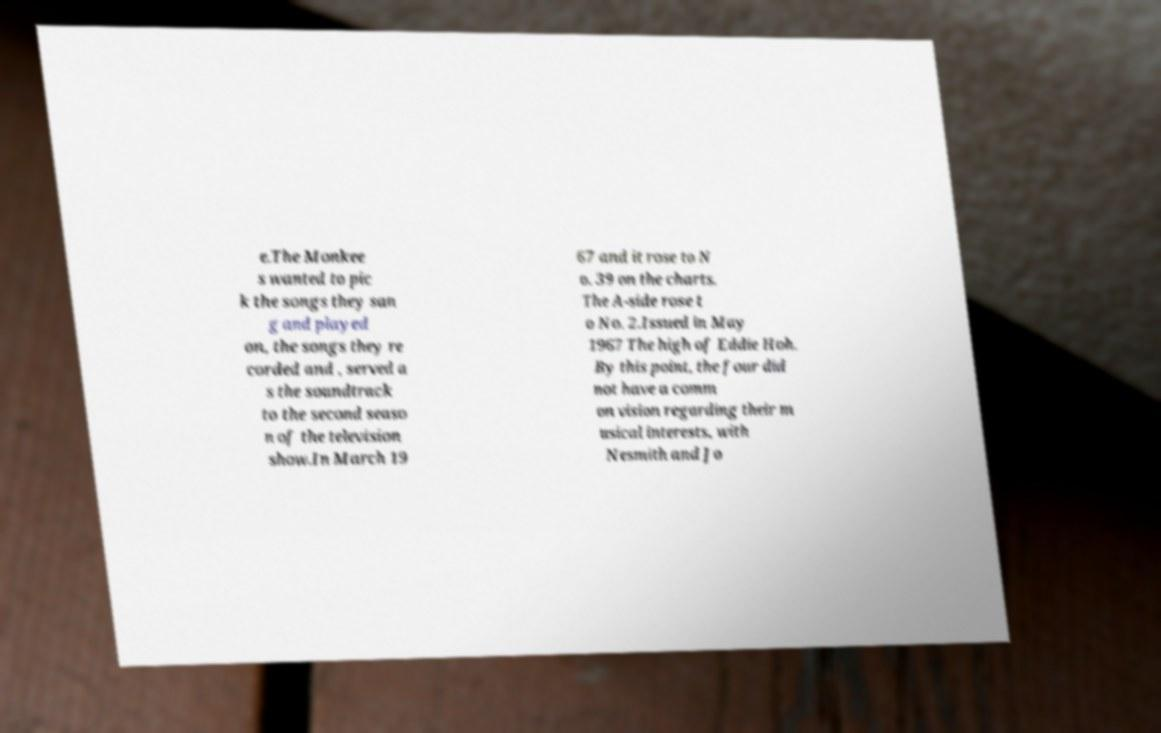Please identify and transcribe the text found in this image. e.The Monkee s wanted to pic k the songs they san g and played on, the songs they re corded and , served a s the soundtrack to the second seaso n of the television show.In March 19 67 and it rose to N o. 39 on the charts. The A-side rose t o No. 2.Issued in May 1967 The high of Eddie Hoh. By this point, the four did not have a comm on vision regarding their m usical interests, with Nesmith and Jo 